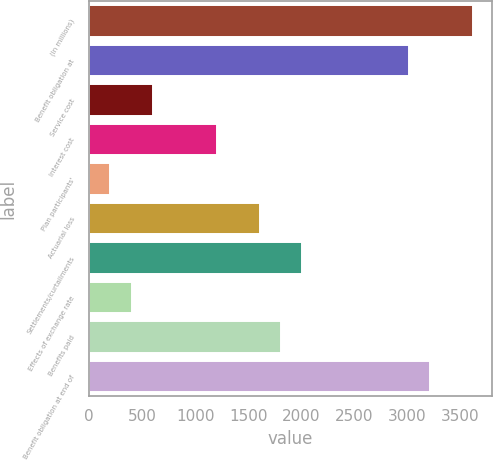Convert chart to OTSL. <chart><loc_0><loc_0><loc_500><loc_500><bar_chart><fcel>(In millions)<fcel>Benefit obligation at<fcel>Service cost<fcel>Interest cost<fcel>Plan participants'<fcel>Actuarial loss<fcel>Settlements/curtailments<fcel>Effects of exchange rate<fcel>Benefits paid<fcel>Benefit obligation at end of<nl><fcel>3617.92<fcel>3014.95<fcel>603.07<fcel>1206.04<fcel>201.09<fcel>1608.02<fcel>2010<fcel>402.08<fcel>1809.01<fcel>3215.94<nl></chart> 